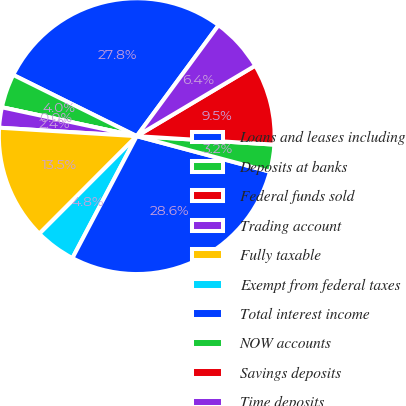<chart> <loc_0><loc_0><loc_500><loc_500><pie_chart><fcel>Loans and leases including<fcel>Deposits at banks<fcel>Federal funds sold<fcel>Trading account<fcel>Fully taxable<fcel>Exempt from federal taxes<fcel>Total interest income<fcel>NOW accounts<fcel>Savings deposits<fcel>Time deposits<nl><fcel>27.78%<fcel>3.97%<fcel>0.0%<fcel>2.38%<fcel>13.49%<fcel>4.76%<fcel>28.57%<fcel>3.17%<fcel>9.52%<fcel>6.35%<nl></chart> 